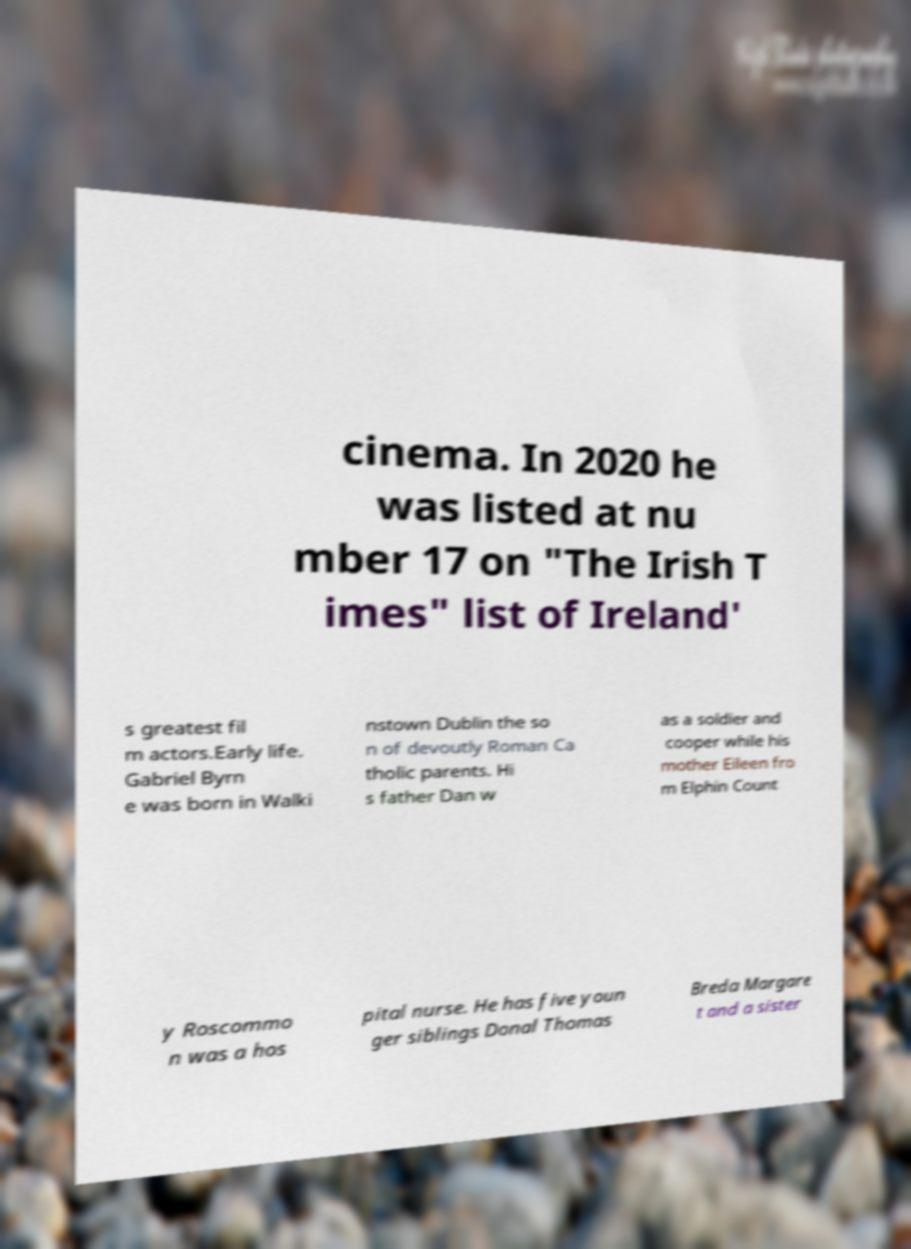Could you extract and type out the text from this image? cinema. In 2020 he was listed at nu mber 17 on "The Irish T imes" list of Ireland' s greatest fil m actors.Early life. Gabriel Byrn e was born in Walki nstown Dublin the so n of devoutly Roman Ca tholic parents. Hi s father Dan w as a soldier and cooper while his mother Eileen fro m Elphin Count y Roscommo n was a hos pital nurse. He has five youn ger siblings Donal Thomas Breda Margare t and a sister 